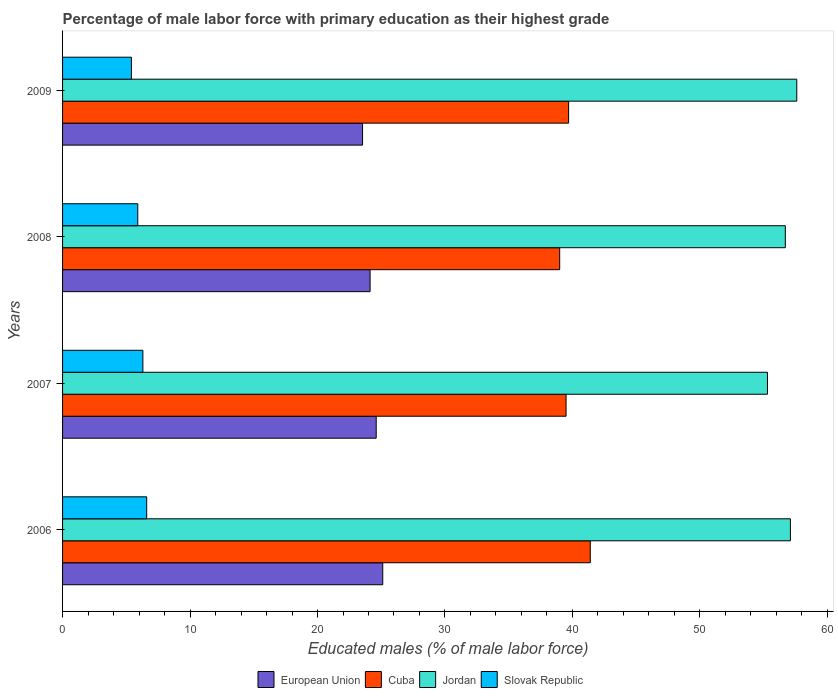How many different coloured bars are there?
Provide a short and direct response. 4. Are the number of bars per tick equal to the number of legend labels?
Make the answer very short. Yes. Are the number of bars on each tick of the Y-axis equal?
Your answer should be very brief. Yes. How many bars are there on the 2nd tick from the bottom?
Ensure brevity in your answer.  4. In how many cases, is the number of bars for a given year not equal to the number of legend labels?
Your answer should be compact. 0. What is the percentage of male labor force with primary education in European Union in 2008?
Give a very brief answer. 24.13. Across all years, what is the maximum percentage of male labor force with primary education in Cuba?
Offer a terse response. 41.4. Across all years, what is the minimum percentage of male labor force with primary education in Jordan?
Your answer should be very brief. 55.3. What is the total percentage of male labor force with primary education in Cuba in the graph?
Keep it short and to the point. 159.6. What is the difference between the percentage of male labor force with primary education in Cuba in 2007 and that in 2008?
Keep it short and to the point. 0.5. What is the difference between the percentage of male labor force with primary education in Cuba in 2008 and the percentage of male labor force with primary education in Slovak Republic in 2007?
Your response must be concise. 32.7. What is the average percentage of male labor force with primary education in Cuba per year?
Offer a terse response. 39.9. In the year 2006, what is the difference between the percentage of male labor force with primary education in European Union and percentage of male labor force with primary education in Jordan?
Make the answer very short. -31.98. What is the ratio of the percentage of male labor force with primary education in Jordan in 2007 to that in 2009?
Your response must be concise. 0.96. Is the difference between the percentage of male labor force with primary education in European Union in 2006 and 2007 greater than the difference between the percentage of male labor force with primary education in Jordan in 2006 and 2007?
Offer a very short reply. No. What is the difference between the highest and the second highest percentage of male labor force with primary education in Cuba?
Offer a very short reply. 1.7. What is the difference between the highest and the lowest percentage of male labor force with primary education in Jordan?
Your answer should be very brief. 2.3. What does the 3rd bar from the top in 2009 represents?
Make the answer very short. Cuba. What does the 4th bar from the bottom in 2008 represents?
Your answer should be very brief. Slovak Republic. Is it the case that in every year, the sum of the percentage of male labor force with primary education in Jordan and percentage of male labor force with primary education in Cuba is greater than the percentage of male labor force with primary education in European Union?
Give a very brief answer. Yes. How many bars are there?
Your response must be concise. 16. Are all the bars in the graph horizontal?
Offer a terse response. Yes. How many years are there in the graph?
Offer a terse response. 4. Where does the legend appear in the graph?
Offer a very short reply. Bottom center. How many legend labels are there?
Make the answer very short. 4. What is the title of the graph?
Provide a short and direct response. Percentage of male labor force with primary education as their highest grade. What is the label or title of the X-axis?
Give a very brief answer. Educated males (% of male labor force). What is the Educated males (% of male labor force) of European Union in 2006?
Ensure brevity in your answer.  25.12. What is the Educated males (% of male labor force) in Cuba in 2006?
Your response must be concise. 41.4. What is the Educated males (% of male labor force) in Jordan in 2006?
Offer a terse response. 57.1. What is the Educated males (% of male labor force) of Slovak Republic in 2006?
Offer a terse response. 6.6. What is the Educated males (% of male labor force) in European Union in 2007?
Make the answer very short. 24.61. What is the Educated males (% of male labor force) in Cuba in 2007?
Give a very brief answer. 39.5. What is the Educated males (% of male labor force) of Jordan in 2007?
Your answer should be compact. 55.3. What is the Educated males (% of male labor force) in Slovak Republic in 2007?
Your answer should be very brief. 6.3. What is the Educated males (% of male labor force) in European Union in 2008?
Ensure brevity in your answer.  24.13. What is the Educated males (% of male labor force) in Cuba in 2008?
Provide a short and direct response. 39. What is the Educated males (% of male labor force) of Jordan in 2008?
Your answer should be very brief. 56.7. What is the Educated males (% of male labor force) in Slovak Republic in 2008?
Ensure brevity in your answer.  5.9. What is the Educated males (% of male labor force) of European Union in 2009?
Your answer should be compact. 23.53. What is the Educated males (% of male labor force) in Cuba in 2009?
Your response must be concise. 39.7. What is the Educated males (% of male labor force) of Jordan in 2009?
Your answer should be very brief. 57.6. What is the Educated males (% of male labor force) of Slovak Republic in 2009?
Ensure brevity in your answer.  5.4. Across all years, what is the maximum Educated males (% of male labor force) of European Union?
Provide a succinct answer. 25.12. Across all years, what is the maximum Educated males (% of male labor force) in Cuba?
Your answer should be very brief. 41.4. Across all years, what is the maximum Educated males (% of male labor force) of Jordan?
Give a very brief answer. 57.6. Across all years, what is the maximum Educated males (% of male labor force) of Slovak Republic?
Keep it short and to the point. 6.6. Across all years, what is the minimum Educated males (% of male labor force) in European Union?
Make the answer very short. 23.53. Across all years, what is the minimum Educated males (% of male labor force) of Cuba?
Make the answer very short. 39. Across all years, what is the minimum Educated males (% of male labor force) of Jordan?
Your answer should be very brief. 55.3. Across all years, what is the minimum Educated males (% of male labor force) in Slovak Republic?
Offer a terse response. 5.4. What is the total Educated males (% of male labor force) of European Union in the graph?
Provide a short and direct response. 97.38. What is the total Educated males (% of male labor force) in Cuba in the graph?
Your answer should be compact. 159.6. What is the total Educated males (% of male labor force) of Jordan in the graph?
Your response must be concise. 226.7. What is the total Educated males (% of male labor force) of Slovak Republic in the graph?
Make the answer very short. 24.2. What is the difference between the Educated males (% of male labor force) in European Union in 2006 and that in 2007?
Give a very brief answer. 0.51. What is the difference between the Educated males (% of male labor force) of Cuba in 2006 and that in 2007?
Offer a terse response. 1.9. What is the difference between the Educated males (% of male labor force) of Jordan in 2006 and that in 2007?
Ensure brevity in your answer.  1.8. What is the difference between the Educated males (% of male labor force) in European Union in 2006 and that in 2008?
Provide a succinct answer. 0.99. What is the difference between the Educated males (% of male labor force) in European Union in 2006 and that in 2009?
Keep it short and to the point. 1.59. What is the difference between the Educated males (% of male labor force) in Cuba in 2006 and that in 2009?
Offer a terse response. 1.7. What is the difference between the Educated males (% of male labor force) in European Union in 2007 and that in 2008?
Ensure brevity in your answer.  0.48. What is the difference between the Educated males (% of male labor force) of Cuba in 2007 and that in 2008?
Give a very brief answer. 0.5. What is the difference between the Educated males (% of male labor force) in Jordan in 2007 and that in 2008?
Offer a terse response. -1.4. What is the difference between the Educated males (% of male labor force) of Slovak Republic in 2007 and that in 2008?
Make the answer very short. 0.4. What is the difference between the Educated males (% of male labor force) of European Union in 2007 and that in 2009?
Your answer should be very brief. 1.07. What is the difference between the Educated males (% of male labor force) in Cuba in 2007 and that in 2009?
Offer a terse response. -0.2. What is the difference between the Educated males (% of male labor force) of Jordan in 2007 and that in 2009?
Offer a very short reply. -2.3. What is the difference between the Educated males (% of male labor force) of European Union in 2008 and that in 2009?
Your response must be concise. 0.59. What is the difference between the Educated males (% of male labor force) of Cuba in 2008 and that in 2009?
Your answer should be compact. -0.7. What is the difference between the Educated males (% of male labor force) in Jordan in 2008 and that in 2009?
Provide a short and direct response. -0.9. What is the difference between the Educated males (% of male labor force) of Slovak Republic in 2008 and that in 2009?
Give a very brief answer. 0.5. What is the difference between the Educated males (% of male labor force) of European Union in 2006 and the Educated males (% of male labor force) of Cuba in 2007?
Offer a very short reply. -14.38. What is the difference between the Educated males (% of male labor force) in European Union in 2006 and the Educated males (% of male labor force) in Jordan in 2007?
Keep it short and to the point. -30.18. What is the difference between the Educated males (% of male labor force) of European Union in 2006 and the Educated males (% of male labor force) of Slovak Republic in 2007?
Provide a short and direct response. 18.82. What is the difference between the Educated males (% of male labor force) of Cuba in 2006 and the Educated males (% of male labor force) of Slovak Republic in 2007?
Provide a succinct answer. 35.1. What is the difference between the Educated males (% of male labor force) in Jordan in 2006 and the Educated males (% of male labor force) in Slovak Republic in 2007?
Your answer should be compact. 50.8. What is the difference between the Educated males (% of male labor force) in European Union in 2006 and the Educated males (% of male labor force) in Cuba in 2008?
Keep it short and to the point. -13.88. What is the difference between the Educated males (% of male labor force) in European Union in 2006 and the Educated males (% of male labor force) in Jordan in 2008?
Make the answer very short. -31.58. What is the difference between the Educated males (% of male labor force) in European Union in 2006 and the Educated males (% of male labor force) in Slovak Republic in 2008?
Your response must be concise. 19.22. What is the difference between the Educated males (% of male labor force) of Cuba in 2006 and the Educated males (% of male labor force) of Jordan in 2008?
Ensure brevity in your answer.  -15.3. What is the difference between the Educated males (% of male labor force) of Cuba in 2006 and the Educated males (% of male labor force) of Slovak Republic in 2008?
Ensure brevity in your answer.  35.5. What is the difference between the Educated males (% of male labor force) of Jordan in 2006 and the Educated males (% of male labor force) of Slovak Republic in 2008?
Provide a succinct answer. 51.2. What is the difference between the Educated males (% of male labor force) in European Union in 2006 and the Educated males (% of male labor force) in Cuba in 2009?
Ensure brevity in your answer.  -14.58. What is the difference between the Educated males (% of male labor force) of European Union in 2006 and the Educated males (% of male labor force) of Jordan in 2009?
Your answer should be compact. -32.48. What is the difference between the Educated males (% of male labor force) of European Union in 2006 and the Educated males (% of male labor force) of Slovak Republic in 2009?
Offer a very short reply. 19.72. What is the difference between the Educated males (% of male labor force) in Cuba in 2006 and the Educated males (% of male labor force) in Jordan in 2009?
Ensure brevity in your answer.  -16.2. What is the difference between the Educated males (% of male labor force) in Cuba in 2006 and the Educated males (% of male labor force) in Slovak Republic in 2009?
Keep it short and to the point. 36. What is the difference between the Educated males (% of male labor force) in Jordan in 2006 and the Educated males (% of male labor force) in Slovak Republic in 2009?
Give a very brief answer. 51.7. What is the difference between the Educated males (% of male labor force) of European Union in 2007 and the Educated males (% of male labor force) of Cuba in 2008?
Offer a very short reply. -14.39. What is the difference between the Educated males (% of male labor force) in European Union in 2007 and the Educated males (% of male labor force) in Jordan in 2008?
Ensure brevity in your answer.  -32.09. What is the difference between the Educated males (% of male labor force) of European Union in 2007 and the Educated males (% of male labor force) of Slovak Republic in 2008?
Provide a short and direct response. 18.71. What is the difference between the Educated males (% of male labor force) of Cuba in 2007 and the Educated males (% of male labor force) of Jordan in 2008?
Offer a very short reply. -17.2. What is the difference between the Educated males (% of male labor force) of Cuba in 2007 and the Educated males (% of male labor force) of Slovak Republic in 2008?
Offer a very short reply. 33.6. What is the difference between the Educated males (% of male labor force) in Jordan in 2007 and the Educated males (% of male labor force) in Slovak Republic in 2008?
Make the answer very short. 49.4. What is the difference between the Educated males (% of male labor force) of European Union in 2007 and the Educated males (% of male labor force) of Cuba in 2009?
Provide a succinct answer. -15.09. What is the difference between the Educated males (% of male labor force) of European Union in 2007 and the Educated males (% of male labor force) of Jordan in 2009?
Keep it short and to the point. -32.99. What is the difference between the Educated males (% of male labor force) in European Union in 2007 and the Educated males (% of male labor force) in Slovak Republic in 2009?
Make the answer very short. 19.21. What is the difference between the Educated males (% of male labor force) of Cuba in 2007 and the Educated males (% of male labor force) of Jordan in 2009?
Provide a short and direct response. -18.1. What is the difference between the Educated males (% of male labor force) of Cuba in 2007 and the Educated males (% of male labor force) of Slovak Republic in 2009?
Provide a short and direct response. 34.1. What is the difference between the Educated males (% of male labor force) of Jordan in 2007 and the Educated males (% of male labor force) of Slovak Republic in 2009?
Ensure brevity in your answer.  49.9. What is the difference between the Educated males (% of male labor force) of European Union in 2008 and the Educated males (% of male labor force) of Cuba in 2009?
Offer a terse response. -15.57. What is the difference between the Educated males (% of male labor force) in European Union in 2008 and the Educated males (% of male labor force) in Jordan in 2009?
Ensure brevity in your answer.  -33.47. What is the difference between the Educated males (% of male labor force) of European Union in 2008 and the Educated males (% of male labor force) of Slovak Republic in 2009?
Ensure brevity in your answer.  18.73. What is the difference between the Educated males (% of male labor force) of Cuba in 2008 and the Educated males (% of male labor force) of Jordan in 2009?
Ensure brevity in your answer.  -18.6. What is the difference between the Educated males (% of male labor force) of Cuba in 2008 and the Educated males (% of male labor force) of Slovak Republic in 2009?
Offer a very short reply. 33.6. What is the difference between the Educated males (% of male labor force) of Jordan in 2008 and the Educated males (% of male labor force) of Slovak Republic in 2009?
Keep it short and to the point. 51.3. What is the average Educated males (% of male labor force) of European Union per year?
Provide a short and direct response. 24.35. What is the average Educated males (% of male labor force) in Cuba per year?
Provide a succinct answer. 39.9. What is the average Educated males (% of male labor force) of Jordan per year?
Keep it short and to the point. 56.67. What is the average Educated males (% of male labor force) of Slovak Republic per year?
Make the answer very short. 6.05. In the year 2006, what is the difference between the Educated males (% of male labor force) in European Union and Educated males (% of male labor force) in Cuba?
Your response must be concise. -16.28. In the year 2006, what is the difference between the Educated males (% of male labor force) in European Union and Educated males (% of male labor force) in Jordan?
Keep it short and to the point. -31.98. In the year 2006, what is the difference between the Educated males (% of male labor force) in European Union and Educated males (% of male labor force) in Slovak Republic?
Your answer should be compact. 18.52. In the year 2006, what is the difference between the Educated males (% of male labor force) in Cuba and Educated males (% of male labor force) in Jordan?
Your answer should be compact. -15.7. In the year 2006, what is the difference between the Educated males (% of male labor force) in Cuba and Educated males (% of male labor force) in Slovak Republic?
Your response must be concise. 34.8. In the year 2006, what is the difference between the Educated males (% of male labor force) in Jordan and Educated males (% of male labor force) in Slovak Republic?
Provide a succinct answer. 50.5. In the year 2007, what is the difference between the Educated males (% of male labor force) in European Union and Educated males (% of male labor force) in Cuba?
Provide a succinct answer. -14.89. In the year 2007, what is the difference between the Educated males (% of male labor force) in European Union and Educated males (% of male labor force) in Jordan?
Provide a succinct answer. -30.69. In the year 2007, what is the difference between the Educated males (% of male labor force) of European Union and Educated males (% of male labor force) of Slovak Republic?
Ensure brevity in your answer.  18.31. In the year 2007, what is the difference between the Educated males (% of male labor force) in Cuba and Educated males (% of male labor force) in Jordan?
Keep it short and to the point. -15.8. In the year 2007, what is the difference between the Educated males (% of male labor force) in Cuba and Educated males (% of male labor force) in Slovak Republic?
Offer a very short reply. 33.2. In the year 2007, what is the difference between the Educated males (% of male labor force) of Jordan and Educated males (% of male labor force) of Slovak Republic?
Offer a terse response. 49. In the year 2008, what is the difference between the Educated males (% of male labor force) in European Union and Educated males (% of male labor force) in Cuba?
Your response must be concise. -14.87. In the year 2008, what is the difference between the Educated males (% of male labor force) of European Union and Educated males (% of male labor force) of Jordan?
Make the answer very short. -32.57. In the year 2008, what is the difference between the Educated males (% of male labor force) of European Union and Educated males (% of male labor force) of Slovak Republic?
Provide a succinct answer. 18.23. In the year 2008, what is the difference between the Educated males (% of male labor force) of Cuba and Educated males (% of male labor force) of Jordan?
Provide a succinct answer. -17.7. In the year 2008, what is the difference between the Educated males (% of male labor force) in Cuba and Educated males (% of male labor force) in Slovak Republic?
Offer a very short reply. 33.1. In the year 2008, what is the difference between the Educated males (% of male labor force) of Jordan and Educated males (% of male labor force) of Slovak Republic?
Give a very brief answer. 50.8. In the year 2009, what is the difference between the Educated males (% of male labor force) of European Union and Educated males (% of male labor force) of Cuba?
Your answer should be very brief. -16.17. In the year 2009, what is the difference between the Educated males (% of male labor force) in European Union and Educated males (% of male labor force) in Jordan?
Your response must be concise. -34.07. In the year 2009, what is the difference between the Educated males (% of male labor force) of European Union and Educated males (% of male labor force) of Slovak Republic?
Keep it short and to the point. 18.13. In the year 2009, what is the difference between the Educated males (% of male labor force) of Cuba and Educated males (% of male labor force) of Jordan?
Keep it short and to the point. -17.9. In the year 2009, what is the difference between the Educated males (% of male labor force) in Cuba and Educated males (% of male labor force) in Slovak Republic?
Keep it short and to the point. 34.3. In the year 2009, what is the difference between the Educated males (% of male labor force) of Jordan and Educated males (% of male labor force) of Slovak Republic?
Offer a terse response. 52.2. What is the ratio of the Educated males (% of male labor force) of European Union in 2006 to that in 2007?
Give a very brief answer. 1.02. What is the ratio of the Educated males (% of male labor force) of Cuba in 2006 to that in 2007?
Your answer should be compact. 1.05. What is the ratio of the Educated males (% of male labor force) in Jordan in 2006 to that in 2007?
Keep it short and to the point. 1.03. What is the ratio of the Educated males (% of male labor force) of Slovak Republic in 2006 to that in 2007?
Your response must be concise. 1.05. What is the ratio of the Educated males (% of male labor force) of European Union in 2006 to that in 2008?
Ensure brevity in your answer.  1.04. What is the ratio of the Educated males (% of male labor force) of Cuba in 2006 to that in 2008?
Your answer should be very brief. 1.06. What is the ratio of the Educated males (% of male labor force) in Jordan in 2006 to that in 2008?
Provide a short and direct response. 1.01. What is the ratio of the Educated males (% of male labor force) of Slovak Republic in 2006 to that in 2008?
Give a very brief answer. 1.12. What is the ratio of the Educated males (% of male labor force) of European Union in 2006 to that in 2009?
Provide a succinct answer. 1.07. What is the ratio of the Educated males (% of male labor force) of Cuba in 2006 to that in 2009?
Keep it short and to the point. 1.04. What is the ratio of the Educated males (% of male labor force) in Slovak Republic in 2006 to that in 2009?
Offer a terse response. 1.22. What is the ratio of the Educated males (% of male labor force) in European Union in 2007 to that in 2008?
Keep it short and to the point. 1.02. What is the ratio of the Educated males (% of male labor force) of Cuba in 2007 to that in 2008?
Ensure brevity in your answer.  1.01. What is the ratio of the Educated males (% of male labor force) of Jordan in 2007 to that in 2008?
Offer a terse response. 0.98. What is the ratio of the Educated males (% of male labor force) in Slovak Republic in 2007 to that in 2008?
Your answer should be compact. 1.07. What is the ratio of the Educated males (% of male labor force) of European Union in 2007 to that in 2009?
Provide a short and direct response. 1.05. What is the ratio of the Educated males (% of male labor force) in Jordan in 2007 to that in 2009?
Offer a very short reply. 0.96. What is the ratio of the Educated males (% of male labor force) of Slovak Republic in 2007 to that in 2009?
Keep it short and to the point. 1.17. What is the ratio of the Educated males (% of male labor force) of European Union in 2008 to that in 2009?
Your response must be concise. 1.03. What is the ratio of the Educated males (% of male labor force) in Cuba in 2008 to that in 2009?
Give a very brief answer. 0.98. What is the ratio of the Educated males (% of male labor force) of Jordan in 2008 to that in 2009?
Keep it short and to the point. 0.98. What is the ratio of the Educated males (% of male labor force) of Slovak Republic in 2008 to that in 2009?
Ensure brevity in your answer.  1.09. What is the difference between the highest and the second highest Educated males (% of male labor force) in European Union?
Give a very brief answer. 0.51. What is the difference between the highest and the second highest Educated males (% of male labor force) in Cuba?
Provide a succinct answer. 1.7. What is the difference between the highest and the second highest Educated males (% of male labor force) of Slovak Republic?
Your answer should be very brief. 0.3. What is the difference between the highest and the lowest Educated males (% of male labor force) of European Union?
Your answer should be very brief. 1.59. What is the difference between the highest and the lowest Educated males (% of male labor force) of Slovak Republic?
Keep it short and to the point. 1.2. 